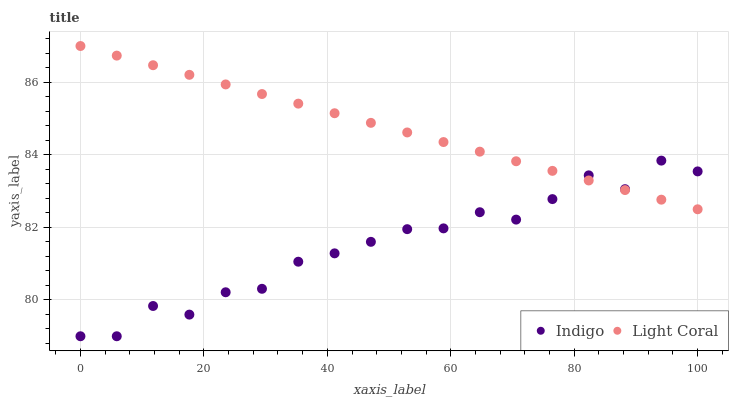Does Indigo have the minimum area under the curve?
Answer yes or no. Yes. Does Light Coral have the maximum area under the curve?
Answer yes or no. Yes. Does Indigo have the maximum area under the curve?
Answer yes or no. No. Is Light Coral the smoothest?
Answer yes or no. Yes. Is Indigo the roughest?
Answer yes or no. Yes. Is Indigo the smoothest?
Answer yes or no. No. Does Indigo have the lowest value?
Answer yes or no. Yes. Does Light Coral have the highest value?
Answer yes or no. Yes. Does Indigo have the highest value?
Answer yes or no. No. Does Light Coral intersect Indigo?
Answer yes or no. Yes. Is Light Coral less than Indigo?
Answer yes or no. No. Is Light Coral greater than Indigo?
Answer yes or no. No. 